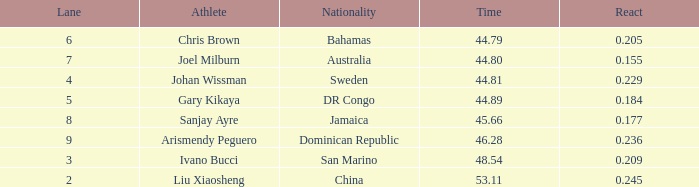What Lane has a 0.209 React entered with a Rank entry that is larger than 6? 2.0. 